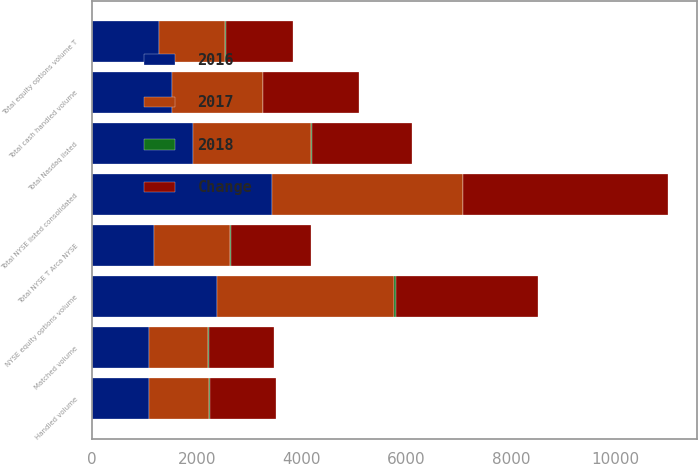Convert chart to OTSL. <chart><loc_0><loc_0><loc_500><loc_500><stacked_bar_chart><ecel><fcel>Handled volume<fcel>Matched volume<fcel>Total NYSE listed consolidated<fcel>Total NYSE T Arca NYSE<fcel>Total Nasdaq listed<fcel>Total cash handled volume<fcel>NYSE equity options volume<fcel>Total equity options volume T<nl><fcel>2017<fcel>1150<fcel>1140<fcel>3647<fcel>1435<fcel>2253<fcel>1734<fcel>3386<fcel>1269<nl><fcel>2016<fcel>1086<fcel>1077<fcel>3434<fcel>1188<fcel>1921<fcel>1521<fcel>2375<fcel>1269<nl><fcel>2018<fcel>6<fcel>6<fcel>6<fcel>21<fcel>17<fcel>14<fcel>43<fcel>24<nl><fcel>Change<fcel>1269<fcel>1256<fcel>3918<fcel>1536<fcel>1907<fcel>1828<fcel>2719<fcel>1269<nl></chart> 